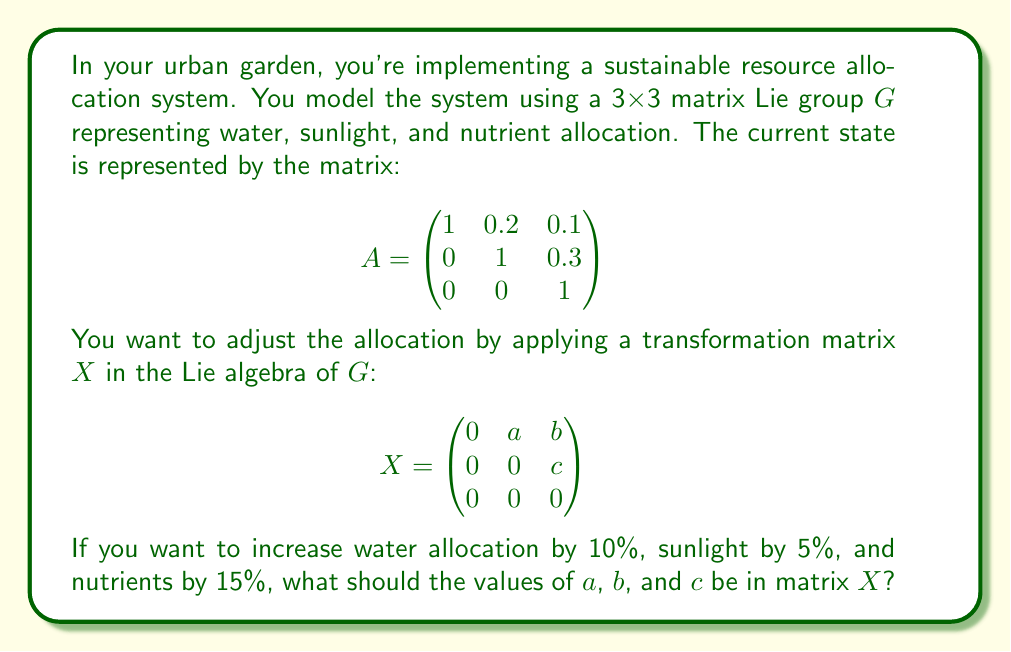Help me with this question. Let's approach this step-by-step:

1) The matrix $A$ represents the current state, and we want to apply a transformation $X$ to achieve the desired changes.

2) In matrix Lie groups, small changes are represented by the matrix exponential of elements in the Lie algebra. The new state after applying $X$ would be:

   $$A' = A \cdot e^X$$

3) For small changes, we can approximate $e^X \approx I + X$, where $I$ is the identity matrix.

4) So, our goal is to find $X$ such that:

   $$A \cdot (I + X) = \begin{pmatrix}
   1.1 & 0.21 & 0.115 \\
   0 & 1.05 & 0.345 \\
   0 & 0 & 1.15
   \end{pmatrix}$$

5) Multiplying out the left side:

   $$\begin{pmatrix}
   1 & 0.2 & 0.1 \\
   0 & 1 & 0.3 \\
   0 & 0 & 1
   \end{pmatrix} \cdot
   \begin{pmatrix}
   1 & a & b \\
   0 & 1 & c \\
   0 & 0 & 1
   \end{pmatrix} =
   \begin{pmatrix}
   1 & 0.2+a & 0.1+b+0.2c \\
   0 & 1 & 0.3+c \\
   0 & 0 & 1
   \end{pmatrix}$$

6) Comparing this with our desired result:

   $0.2 + a = 0.21$, so $a = 0.01$
   $1 + c = 1.05$, so $c = 0.05$
   $0.1 + b + 0.2c = 0.115$, so $b + 0.2(0.05) = 0.015$, thus $b = 0.005$

Therefore, the values for $a$, $b$, and $c$ in matrix $X$ should be 0.01, 0.005, and 0.05 respectively.
Answer: $a = 0.01$, $b = 0.005$, $c = 0.05$ 